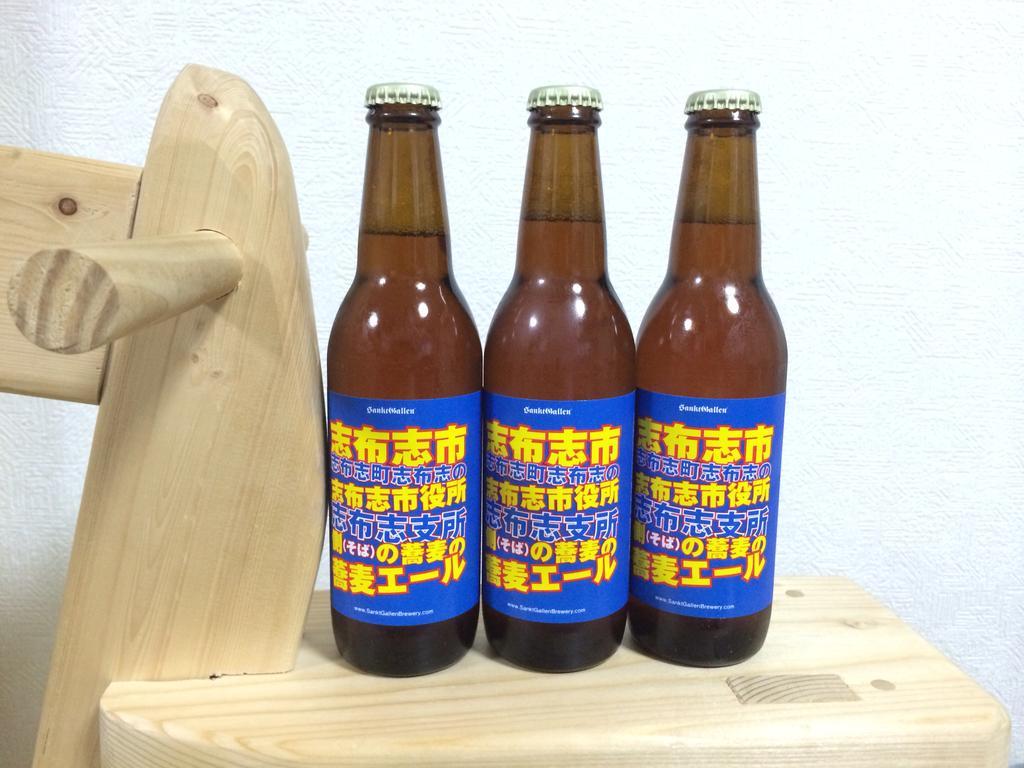In one or two sentences, can you explain what this image depicts? These 3 bottles are highlighted in this picture. This is a wood. These 3 bottles have sticker and filled with liquids. 